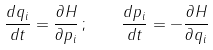<formula> <loc_0><loc_0><loc_500><loc_500>\frac { d q _ { i } } { d t } = \frac { \partial H } { \partial p _ { i } } \, ; \quad \frac { d p _ { i } } { d t } = - \frac { \partial H } { \partial q _ { i } }</formula> 